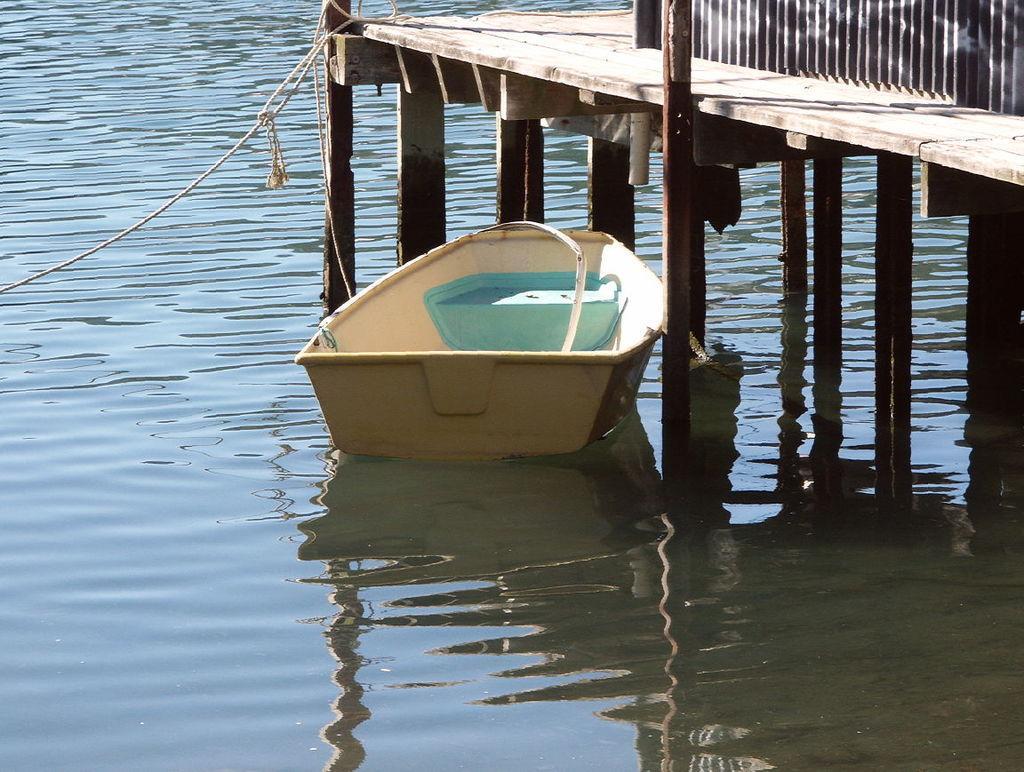In one or two sentences, can you explain what this image depicts? In this picture we can see a boat in the water, and the boat is tied with rope, beside to the boat we can find a metal rod and a bridge. 